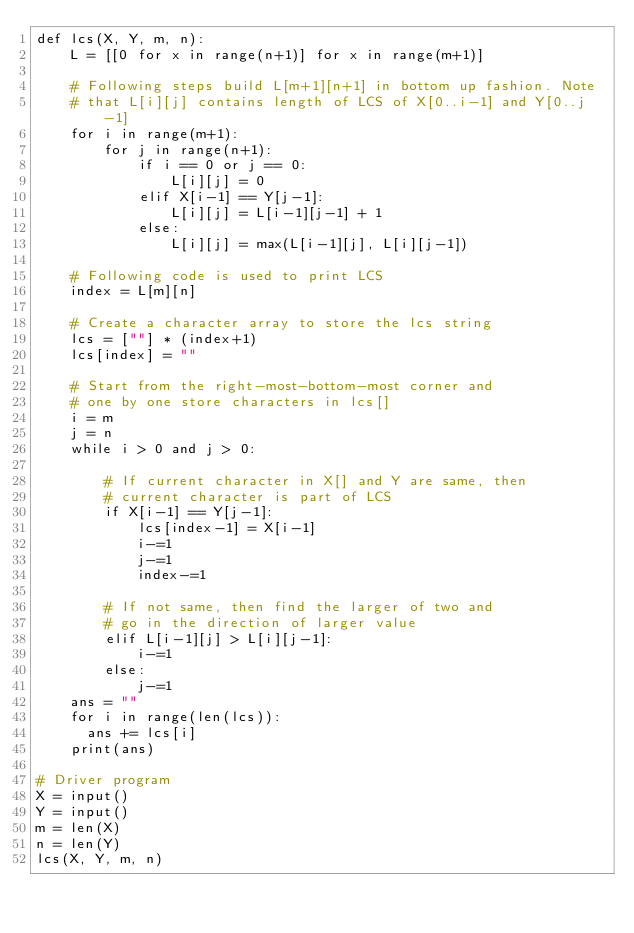<code> <loc_0><loc_0><loc_500><loc_500><_Python_>def lcs(X, Y, m, n): 
    L = [[0 for x in range(n+1)] for x in range(m+1)] 
  
    # Following steps build L[m+1][n+1] in bottom up fashion. Note 
    # that L[i][j] contains length of LCS of X[0..i-1] and Y[0..j-1]  
    for i in range(m+1): 
        for j in range(n+1): 
            if i == 0 or j == 0: 
                L[i][j] = 0
            elif X[i-1] == Y[j-1]: 
                L[i][j] = L[i-1][j-1] + 1
            else: 
                L[i][j] = max(L[i-1][j], L[i][j-1]) 
  
    # Following code is used to print LCS 
    index = L[m][n] 
  
    # Create a character array to store the lcs string 
    lcs = [""] * (index+1) 
    lcs[index] = "" 
  
    # Start from the right-most-bottom-most corner and 
    # one by one store characters in lcs[] 
    i = m 
    j = n 
    while i > 0 and j > 0: 
  
        # If current character in X[] and Y are same, then 
        # current character is part of LCS 
        if X[i-1] == Y[j-1]: 
            lcs[index-1] = X[i-1] 
            i-=1
            j-=1
            index-=1
  
        # If not same, then find the larger of two and 
        # go in the direction of larger value 
        elif L[i-1][j] > L[i][j-1]: 
            i-=1
        else: 
            j-=1
    ans = ""
    for i in range(len(lcs)):
      ans += lcs[i]
    print(ans)
  
# Driver program 
X = input()
Y = input()
m = len(X) 
n = len(Y) 
lcs(X, Y, m, n) </code> 